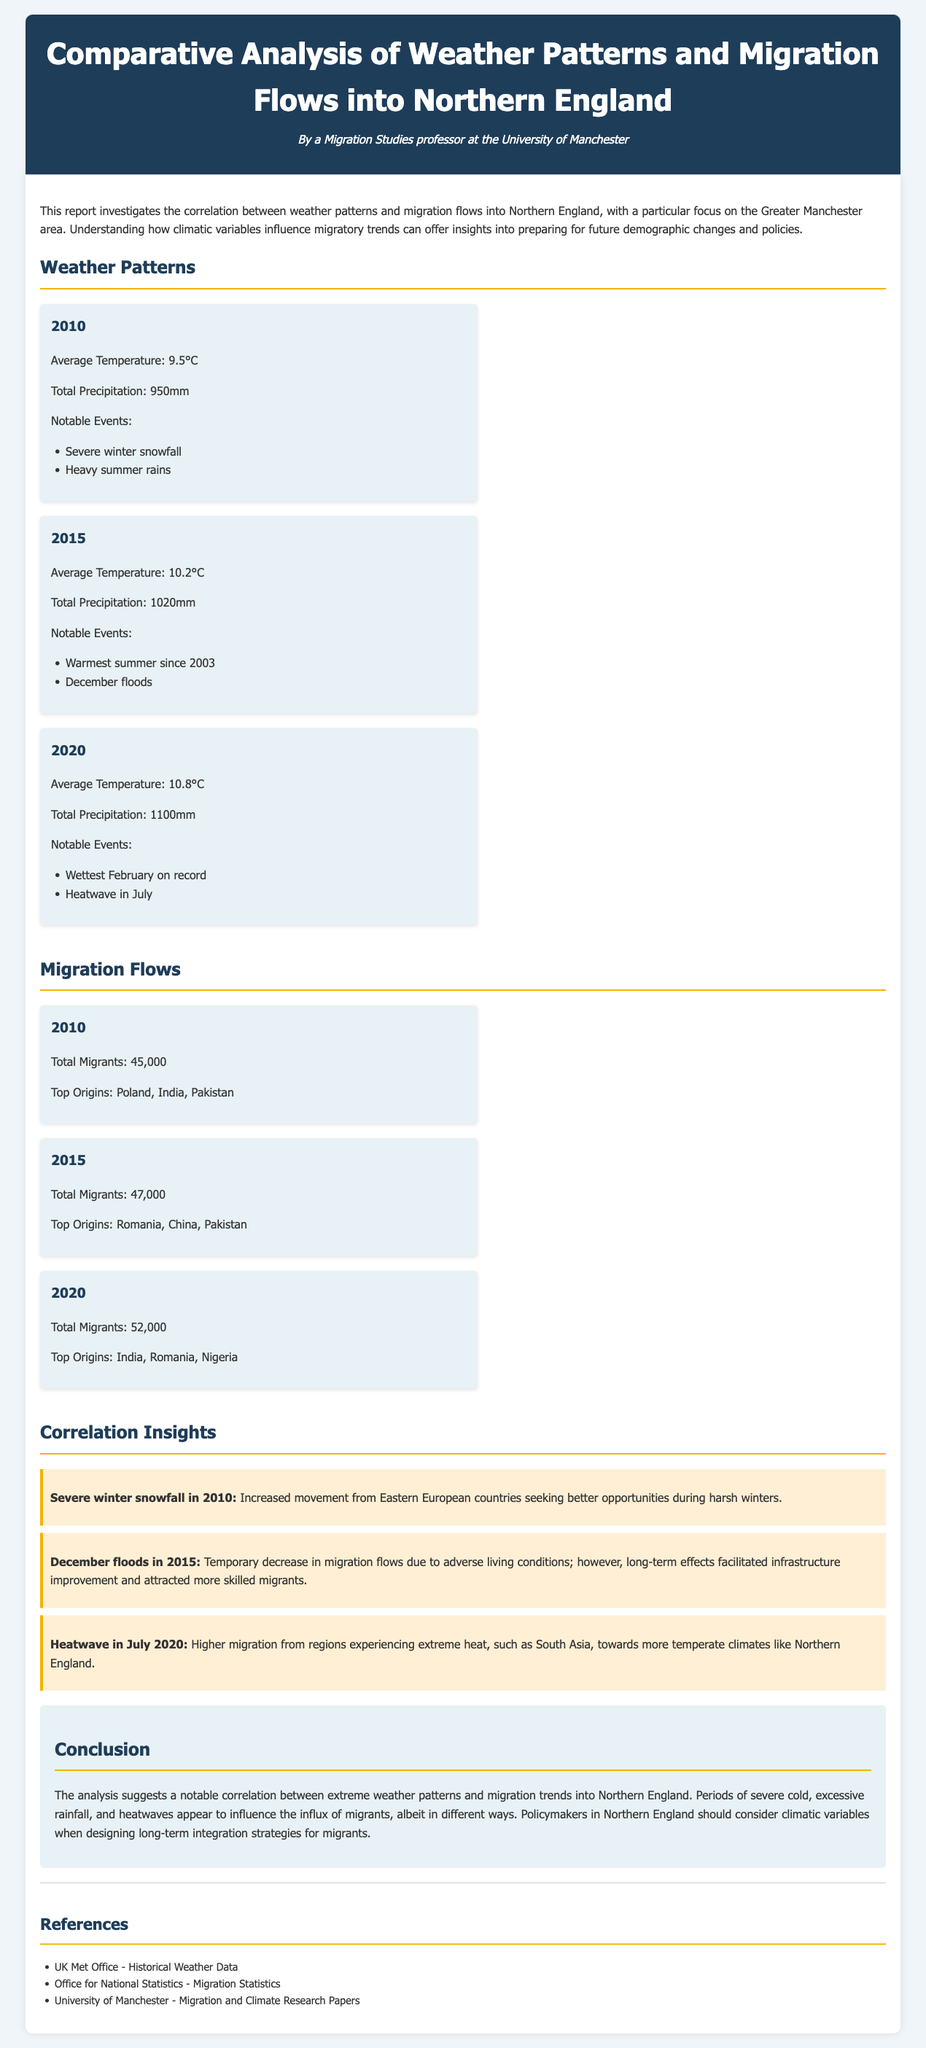What was the average temperature in 2015? The temperature recorded in 2015 within the document was 10.2°C.
Answer: 10.2°C What notable event occurred in July 2020? The document states that a heatwave was the notable event in July 2020.
Answer: Heatwave How many total migrants arrived in 2020? According to the migration flows data, the total number of migrants in 2020 was 52,000.
Answer: 52,000 Which year had the highest total precipitation? The document indicates that 2020 had the highest precipitation at 1100mm.
Answer: 2020 What was the top origin of migrants in 2015? The main origin of migrants in 2015 was Romania.
Answer: Romania What correlation is noted with December floods in 2015? The document emphasizes that the December floods temporarily decreased migration flows.
Answer: Decreased migration flows Which weather event in 2010 influences Eastern European migration? The report mentions that severe winter snowfall in 2010 affected migration from Eastern Europe.
Answer: Severe winter snowfall What policy consideration is suggested regarding migration and weather? The document suggests that policymakers should consider climatic variables in their strategies.
Answer: Climatic variables What type of weather event drove higher migration from South Asia in 2020? A heatwave during July 2020 influenced higher migration from South Asia.
Answer: Heatwave 